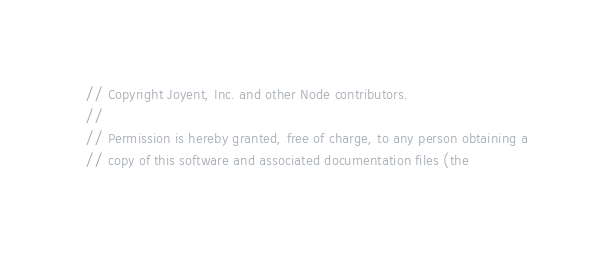<code> <loc_0><loc_0><loc_500><loc_500><_JavaScript_>// Copyright Joyent, Inc. and other Node contributors.
//
// Permission is hereby granted, free of charge, to any person obtaining a
// copy of this software and associated documentation files (the</code> 